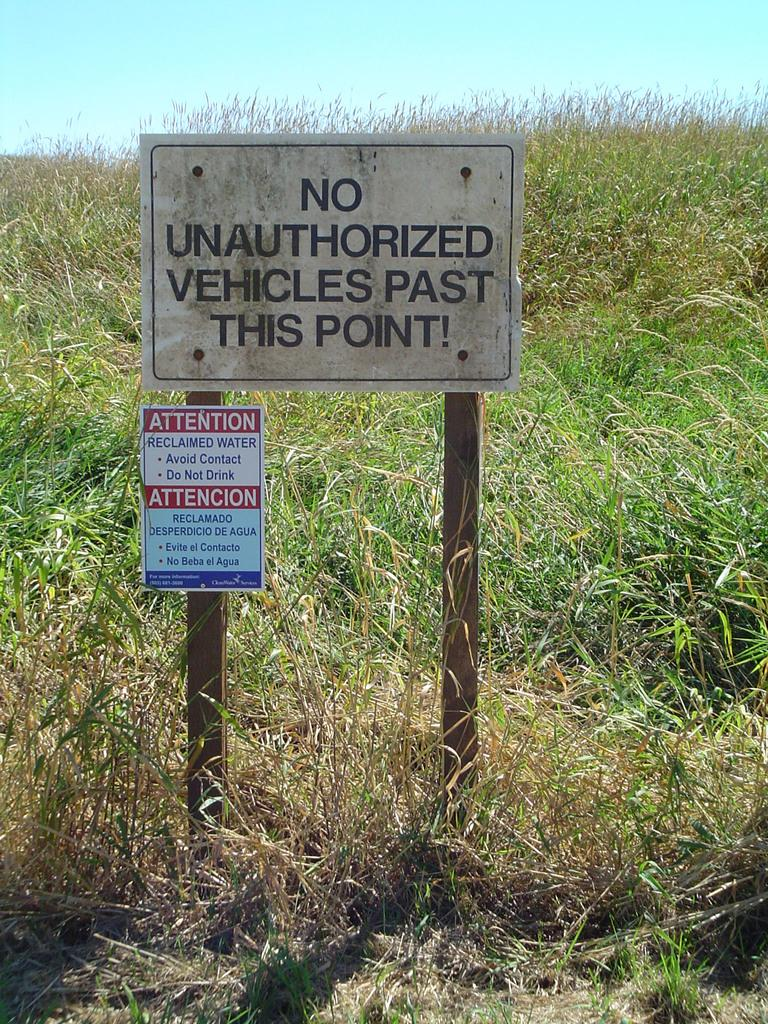What is the main object in the middle of the image? There is a caution board in the middle of the image. What type of natural environment is visible in the background? There is grass in the background of the image. What type of vegetation is present at the bottom of the image? There are small plants at the bottom of the image. What is visible at the top of the image? The sky is visible at the top of the image. How many sisters are holding the caution board in the image? There are no sisters present in the image, and the caution board is not being held by anyone. 